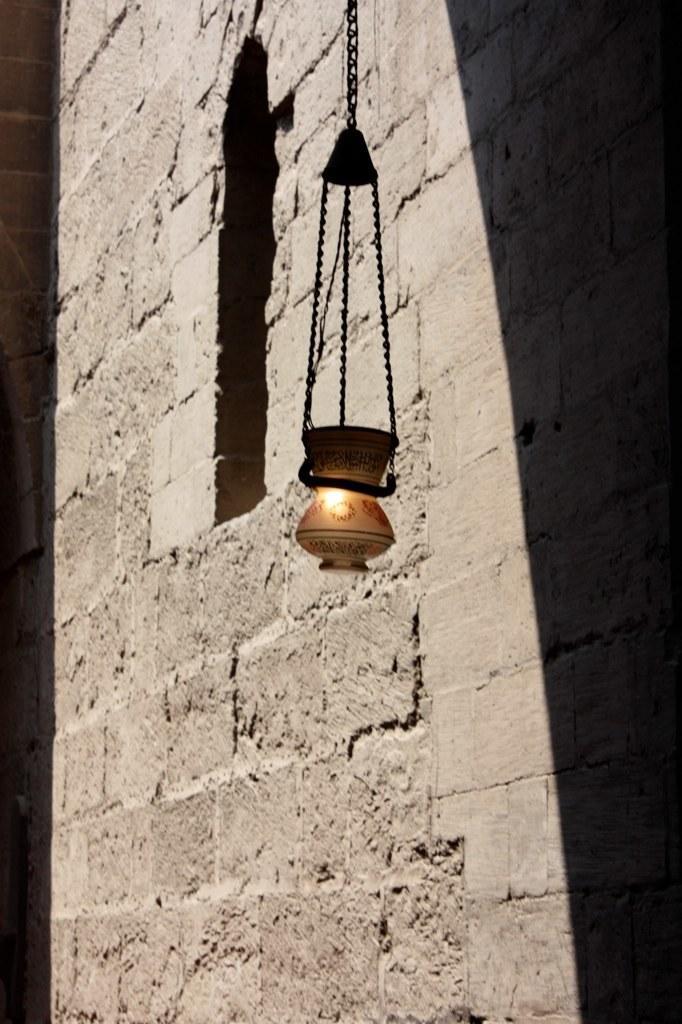Describe this image in one or two sentences. In this image we can see a brick wall. Also there is an object hangs with chain. Also there is light. 